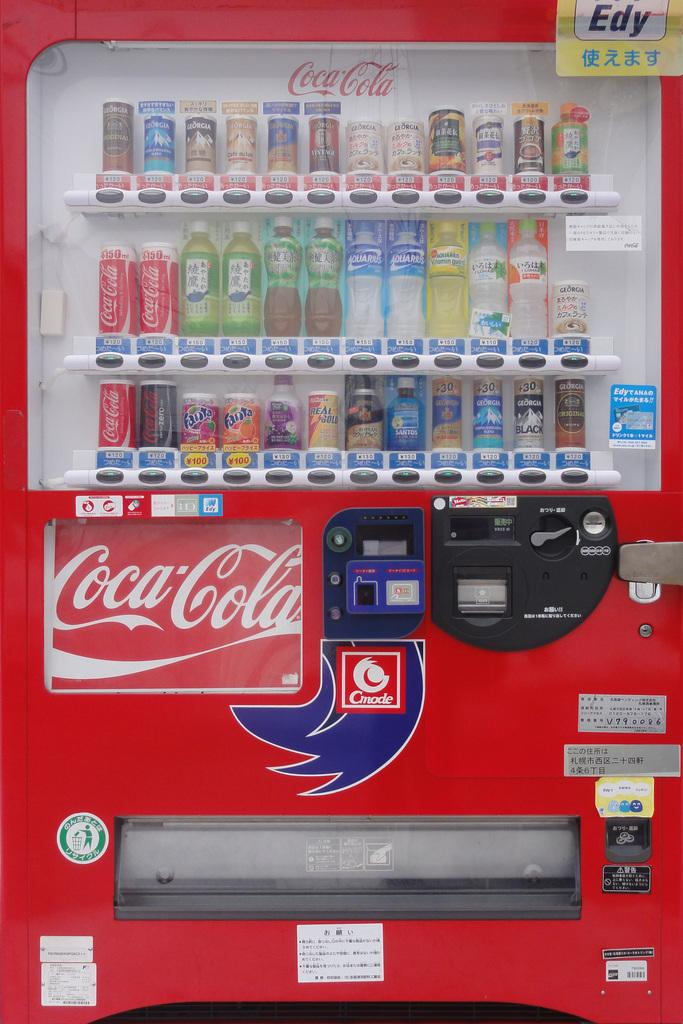<image>
Offer a succinct explanation of the picture presented. A coca-cola machine filled with all sorts of coke products to drink. 